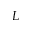Convert formula to latex. <formula><loc_0><loc_0><loc_500><loc_500>L</formula> 